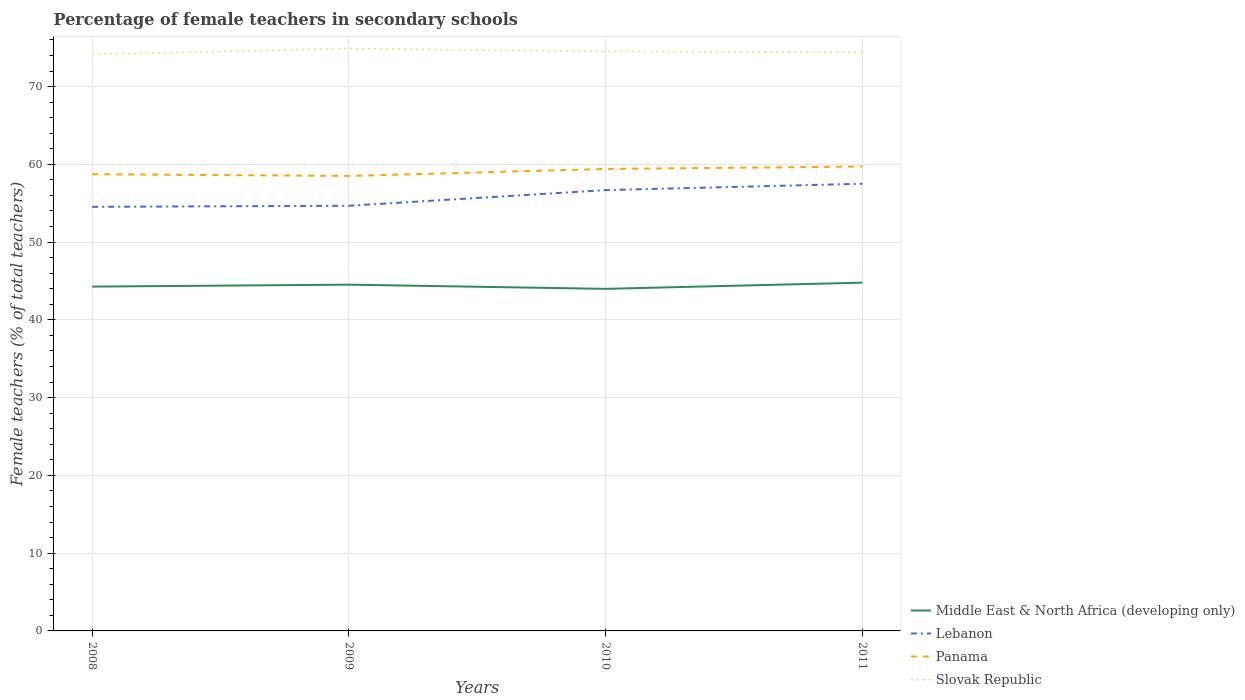Across all years, what is the maximum percentage of female teachers in Panama?
Offer a terse response. 58.5. What is the total percentage of female teachers in Slovak Republic in the graph?
Give a very brief answer. -0.74. What is the difference between the highest and the second highest percentage of female teachers in Middle East & North Africa (developing only)?
Ensure brevity in your answer.  0.8. Is the percentage of female teachers in Panama strictly greater than the percentage of female teachers in Lebanon over the years?
Provide a short and direct response. No. Are the values on the major ticks of Y-axis written in scientific E-notation?
Your answer should be very brief. No. Does the graph contain any zero values?
Offer a terse response. No. Does the graph contain grids?
Ensure brevity in your answer.  Yes. How many legend labels are there?
Offer a very short reply. 4. What is the title of the graph?
Provide a succinct answer. Percentage of female teachers in secondary schools. What is the label or title of the X-axis?
Your answer should be very brief. Years. What is the label or title of the Y-axis?
Provide a succinct answer. Female teachers (% of total teachers). What is the Female teachers (% of total teachers) of Middle East & North Africa (developing only) in 2008?
Your answer should be very brief. 44.28. What is the Female teachers (% of total teachers) in Lebanon in 2008?
Give a very brief answer. 54.53. What is the Female teachers (% of total teachers) in Panama in 2008?
Ensure brevity in your answer.  58.72. What is the Female teachers (% of total teachers) of Slovak Republic in 2008?
Offer a terse response. 74.15. What is the Female teachers (% of total teachers) of Middle East & North Africa (developing only) in 2009?
Make the answer very short. 44.53. What is the Female teachers (% of total teachers) of Lebanon in 2009?
Provide a succinct answer. 54.67. What is the Female teachers (% of total teachers) in Panama in 2009?
Ensure brevity in your answer.  58.5. What is the Female teachers (% of total teachers) of Slovak Republic in 2009?
Make the answer very short. 74.88. What is the Female teachers (% of total teachers) in Middle East & North Africa (developing only) in 2010?
Provide a short and direct response. 43.99. What is the Female teachers (% of total teachers) of Lebanon in 2010?
Your answer should be very brief. 56.68. What is the Female teachers (% of total teachers) of Panama in 2010?
Make the answer very short. 59.4. What is the Female teachers (% of total teachers) of Slovak Republic in 2010?
Provide a succinct answer. 74.52. What is the Female teachers (% of total teachers) of Middle East & North Africa (developing only) in 2011?
Offer a very short reply. 44.78. What is the Female teachers (% of total teachers) in Lebanon in 2011?
Provide a short and direct response. 57.5. What is the Female teachers (% of total teachers) in Panama in 2011?
Give a very brief answer. 59.72. What is the Female teachers (% of total teachers) of Slovak Republic in 2011?
Keep it short and to the point. 74.4. Across all years, what is the maximum Female teachers (% of total teachers) of Middle East & North Africa (developing only)?
Your answer should be compact. 44.78. Across all years, what is the maximum Female teachers (% of total teachers) of Lebanon?
Offer a very short reply. 57.5. Across all years, what is the maximum Female teachers (% of total teachers) of Panama?
Your answer should be very brief. 59.72. Across all years, what is the maximum Female teachers (% of total teachers) of Slovak Republic?
Provide a short and direct response. 74.88. Across all years, what is the minimum Female teachers (% of total teachers) in Middle East & North Africa (developing only)?
Make the answer very short. 43.99. Across all years, what is the minimum Female teachers (% of total teachers) in Lebanon?
Offer a very short reply. 54.53. Across all years, what is the minimum Female teachers (% of total teachers) of Panama?
Make the answer very short. 58.5. Across all years, what is the minimum Female teachers (% of total teachers) of Slovak Republic?
Offer a very short reply. 74.15. What is the total Female teachers (% of total teachers) of Middle East & North Africa (developing only) in the graph?
Your answer should be very brief. 177.57. What is the total Female teachers (% of total teachers) in Lebanon in the graph?
Offer a terse response. 223.39. What is the total Female teachers (% of total teachers) in Panama in the graph?
Your response must be concise. 236.35. What is the total Female teachers (% of total teachers) of Slovak Republic in the graph?
Your answer should be compact. 297.95. What is the difference between the Female teachers (% of total teachers) of Middle East & North Africa (developing only) in 2008 and that in 2009?
Your answer should be very brief. -0.25. What is the difference between the Female teachers (% of total teachers) of Lebanon in 2008 and that in 2009?
Your answer should be compact. -0.14. What is the difference between the Female teachers (% of total teachers) in Panama in 2008 and that in 2009?
Your answer should be compact. 0.22. What is the difference between the Female teachers (% of total teachers) in Slovak Republic in 2008 and that in 2009?
Offer a very short reply. -0.74. What is the difference between the Female teachers (% of total teachers) in Middle East & North Africa (developing only) in 2008 and that in 2010?
Provide a succinct answer. 0.29. What is the difference between the Female teachers (% of total teachers) in Lebanon in 2008 and that in 2010?
Your answer should be compact. -2.15. What is the difference between the Female teachers (% of total teachers) of Panama in 2008 and that in 2010?
Your answer should be compact. -0.68. What is the difference between the Female teachers (% of total teachers) in Slovak Republic in 2008 and that in 2010?
Ensure brevity in your answer.  -0.38. What is the difference between the Female teachers (% of total teachers) of Middle East & North Africa (developing only) in 2008 and that in 2011?
Your answer should be compact. -0.51. What is the difference between the Female teachers (% of total teachers) in Lebanon in 2008 and that in 2011?
Your answer should be compact. -2.97. What is the difference between the Female teachers (% of total teachers) in Panama in 2008 and that in 2011?
Give a very brief answer. -0.99. What is the difference between the Female teachers (% of total teachers) of Slovak Republic in 2008 and that in 2011?
Give a very brief answer. -0.25. What is the difference between the Female teachers (% of total teachers) in Middle East & North Africa (developing only) in 2009 and that in 2010?
Ensure brevity in your answer.  0.54. What is the difference between the Female teachers (% of total teachers) of Lebanon in 2009 and that in 2010?
Provide a short and direct response. -2.01. What is the difference between the Female teachers (% of total teachers) of Panama in 2009 and that in 2010?
Give a very brief answer. -0.9. What is the difference between the Female teachers (% of total teachers) in Slovak Republic in 2009 and that in 2010?
Offer a very short reply. 0.36. What is the difference between the Female teachers (% of total teachers) of Middle East & North Africa (developing only) in 2009 and that in 2011?
Your answer should be compact. -0.26. What is the difference between the Female teachers (% of total teachers) in Lebanon in 2009 and that in 2011?
Offer a terse response. -2.83. What is the difference between the Female teachers (% of total teachers) in Panama in 2009 and that in 2011?
Offer a terse response. -1.22. What is the difference between the Female teachers (% of total teachers) in Slovak Republic in 2009 and that in 2011?
Provide a short and direct response. 0.49. What is the difference between the Female teachers (% of total teachers) of Middle East & North Africa (developing only) in 2010 and that in 2011?
Provide a short and direct response. -0.8. What is the difference between the Female teachers (% of total teachers) in Lebanon in 2010 and that in 2011?
Give a very brief answer. -0.82. What is the difference between the Female teachers (% of total teachers) of Panama in 2010 and that in 2011?
Provide a succinct answer. -0.32. What is the difference between the Female teachers (% of total teachers) in Slovak Republic in 2010 and that in 2011?
Ensure brevity in your answer.  0.13. What is the difference between the Female teachers (% of total teachers) in Middle East & North Africa (developing only) in 2008 and the Female teachers (% of total teachers) in Lebanon in 2009?
Ensure brevity in your answer.  -10.4. What is the difference between the Female teachers (% of total teachers) of Middle East & North Africa (developing only) in 2008 and the Female teachers (% of total teachers) of Panama in 2009?
Offer a terse response. -14.23. What is the difference between the Female teachers (% of total teachers) of Middle East & North Africa (developing only) in 2008 and the Female teachers (% of total teachers) of Slovak Republic in 2009?
Your answer should be compact. -30.61. What is the difference between the Female teachers (% of total teachers) of Lebanon in 2008 and the Female teachers (% of total teachers) of Panama in 2009?
Offer a terse response. -3.97. What is the difference between the Female teachers (% of total teachers) in Lebanon in 2008 and the Female teachers (% of total teachers) in Slovak Republic in 2009?
Give a very brief answer. -20.35. What is the difference between the Female teachers (% of total teachers) in Panama in 2008 and the Female teachers (% of total teachers) in Slovak Republic in 2009?
Make the answer very short. -16.16. What is the difference between the Female teachers (% of total teachers) of Middle East & North Africa (developing only) in 2008 and the Female teachers (% of total teachers) of Lebanon in 2010?
Give a very brief answer. -12.41. What is the difference between the Female teachers (% of total teachers) in Middle East & North Africa (developing only) in 2008 and the Female teachers (% of total teachers) in Panama in 2010?
Keep it short and to the point. -15.13. What is the difference between the Female teachers (% of total teachers) of Middle East & North Africa (developing only) in 2008 and the Female teachers (% of total teachers) of Slovak Republic in 2010?
Provide a short and direct response. -30.25. What is the difference between the Female teachers (% of total teachers) of Lebanon in 2008 and the Female teachers (% of total teachers) of Panama in 2010?
Your answer should be very brief. -4.87. What is the difference between the Female teachers (% of total teachers) of Lebanon in 2008 and the Female teachers (% of total teachers) of Slovak Republic in 2010?
Offer a very short reply. -19.99. What is the difference between the Female teachers (% of total teachers) in Panama in 2008 and the Female teachers (% of total teachers) in Slovak Republic in 2010?
Offer a terse response. -15.8. What is the difference between the Female teachers (% of total teachers) in Middle East & North Africa (developing only) in 2008 and the Female teachers (% of total teachers) in Lebanon in 2011?
Your answer should be very brief. -13.23. What is the difference between the Female teachers (% of total teachers) in Middle East & North Africa (developing only) in 2008 and the Female teachers (% of total teachers) in Panama in 2011?
Keep it short and to the point. -15.44. What is the difference between the Female teachers (% of total teachers) in Middle East & North Africa (developing only) in 2008 and the Female teachers (% of total teachers) in Slovak Republic in 2011?
Your answer should be compact. -30.12. What is the difference between the Female teachers (% of total teachers) of Lebanon in 2008 and the Female teachers (% of total teachers) of Panama in 2011?
Your answer should be very brief. -5.19. What is the difference between the Female teachers (% of total teachers) of Lebanon in 2008 and the Female teachers (% of total teachers) of Slovak Republic in 2011?
Your answer should be very brief. -19.86. What is the difference between the Female teachers (% of total teachers) of Panama in 2008 and the Female teachers (% of total teachers) of Slovak Republic in 2011?
Ensure brevity in your answer.  -15.67. What is the difference between the Female teachers (% of total teachers) of Middle East & North Africa (developing only) in 2009 and the Female teachers (% of total teachers) of Lebanon in 2010?
Ensure brevity in your answer.  -12.16. What is the difference between the Female teachers (% of total teachers) in Middle East & North Africa (developing only) in 2009 and the Female teachers (% of total teachers) in Panama in 2010?
Give a very brief answer. -14.88. What is the difference between the Female teachers (% of total teachers) in Middle East & North Africa (developing only) in 2009 and the Female teachers (% of total teachers) in Slovak Republic in 2010?
Your answer should be very brief. -30. What is the difference between the Female teachers (% of total teachers) in Lebanon in 2009 and the Female teachers (% of total teachers) in Panama in 2010?
Your answer should be very brief. -4.73. What is the difference between the Female teachers (% of total teachers) of Lebanon in 2009 and the Female teachers (% of total teachers) of Slovak Republic in 2010?
Offer a very short reply. -19.85. What is the difference between the Female teachers (% of total teachers) of Panama in 2009 and the Female teachers (% of total teachers) of Slovak Republic in 2010?
Your answer should be compact. -16.02. What is the difference between the Female teachers (% of total teachers) of Middle East & North Africa (developing only) in 2009 and the Female teachers (% of total teachers) of Lebanon in 2011?
Give a very brief answer. -12.98. What is the difference between the Female teachers (% of total teachers) in Middle East & North Africa (developing only) in 2009 and the Female teachers (% of total teachers) in Panama in 2011?
Provide a succinct answer. -15.19. What is the difference between the Female teachers (% of total teachers) in Middle East & North Africa (developing only) in 2009 and the Female teachers (% of total teachers) in Slovak Republic in 2011?
Provide a succinct answer. -29.87. What is the difference between the Female teachers (% of total teachers) of Lebanon in 2009 and the Female teachers (% of total teachers) of Panama in 2011?
Ensure brevity in your answer.  -5.05. What is the difference between the Female teachers (% of total teachers) of Lebanon in 2009 and the Female teachers (% of total teachers) of Slovak Republic in 2011?
Keep it short and to the point. -19.72. What is the difference between the Female teachers (% of total teachers) in Panama in 2009 and the Female teachers (% of total teachers) in Slovak Republic in 2011?
Give a very brief answer. -15.89. What is the difference between the Female teachers (% of total teachers) in Middle East & North Africa (developing only) in 2010 and the Female teachers (% of total teachers) in Lebanon in 2011?
Offer a very short reply. -13.52. What is the difference between the Female teachers (% of total teachers) in Middle East & North Africa (developing only) in 2010 and the Female teachers (% of total teachers) in Panama in 2011?
Keep it short and to the point. -15.73. What is the difference between the Female teachers (% of total teachers) in Middle East & North Africa (developing only) in 2010 and the Female teachers (% of total teachers) in Slovak Republic in 2011?
Give a very brief answer. -30.41. What is the difference between the Female teachers (% of total teachers) in Lebanon in 2010 and the Female teachers (% of total teachers) in Panama in 2011?
Keep it short and to the point. -3.03. What is the difference between the Female teachers (% of total teachers) in Lebanon in 2010 and the Female teachers (% of total teachers) in Slovak Republic in 2011?
Ensure brevity in your answer.  -17.71. What is the difference between the Female teachers (% of total teachers) of Panama in 2010 and the Female teachers (% of total teachers) of Slovak Republic in 2011?
Your answer should be very brief. -14.99. What is the average Female teachers (% of total teachers) of Middle East & North Africa (developing only) per year?
Make the answer very short. 44.39. What is the average Female teachers (% of total teachers) in Lebanon per year?
Your response must be concise. 55.85. What is the average Female teachers (% of total teachers) in Panama per year?
Make the answer very short. 59.09. What is the average Female teachers (% of total teachers) in Slovak Republic per year?
Offer a very short reply. 74.49. In the year 2008, what is the difference between the Female teachers (% of total teachers) in Middle East & North Africa (developing only) and Female teachers (% of total teachers) in Lebanon?
Give a very brief answer. -10.26. In the year 2008, what is the difference between the Female teachers (% of total teachers) of Middle East & North Africa (developing only) and Female teachers (% of total teachers) of Panama?
Your answer should be compact. -14.45. In the year 2008, what is the difference between the Female teachers (% of total teachers) in Middle East & North Africa (developing only) and Female teachers (% of total teachers) in Slovak Republic?
Your answer should be compact. -29.87. In the year 2008, what is the difference between the Female teachers (% of total teachers) of Lebanon and Female teachers (% of total teachers) of Panama?
Provide a short and direct response. -4.19. In the year 2008, what is the difference between the Female teachers (% of total teachers) in Lebanon and Female teachers (% of total teachers) in Slovak Republic?
Keep it short and to the point. -19.61. In the year 2008, what is the difference between the Female teachers (% of total teachers) of Panama and Female teachers (% of total teachers) of Slovak Republic?
Offer a terse response. -15.42. In the year 2009, what is the difference between the Female teachers (% of total teachers) of Middle East & North Africa (developing only) and Female teachers (% of total teachers) of Lebanon?
Make the answer very short. -10.15. In the year 2009, what is the difference between the Female teachers (% of total teachers) of Middle East & North Africa (developing only) and Female teachers (% of total teachers) of Panama?
Your answer should be compact. -13.98. In the year 2009, what is the difference between the Female teachers (% of total teachers) in Middle East & North Africa (developing only) and Female teachers (% of total teachers) in Slovak Republic?
Offer a very short reply. -30.36. In the year 2009, what is the difference between the Female teachers (% of total teachers) in Lebanon and Female teachers (% of total teachers) in Panama?
Your answer should be compact. -3.83. In the year 2009, what is the difference between the Female teachers (% of total teachers) of Lebanon and Female teachers (% of total teachers) of Slovak Republic?
Keep it short and to the point. -20.21. In the year 2009, what is the difference between the Female teachers (% of total teachers) of Panama and Female teachers (% of total teachers) of Slovak Republic?
Make the answer very short. -16.38. In the year 2010, what is the difference between the Female teachers (% of total teachers) of Middle East & North Africa (developing only) and Female teachers (% of total teachers) of Lebanon?
Keep it short and to the point. -12.7. In the year 2010, what is the difference between the Female teachers (% of total teachers) in Middle East & North Africa (developing only) and Female teachers (% of total teachers) in Panama?
Ensure brevity in your answer.  -15.42. In the year 2010, what is the difference between the Female teachers (% of total teachers) in Middle East & North Africa (developing only) and Female teachers (% of total teachers) in Slovak Republic?
Your response must be concise. -30.54. In the year 2010, what is the difference between the Female teachers (% of total teachers) in Lebanon and Female teachers (% of total teachers) in Panama?
Offer a very short reply. -2.72. In the year 2010, what is the difference between the Female teachers (% of total teachers) in Lebanon and Female teachers (% of total teachers) in Slovak Republic?
Make the answer very short. -17.84. In the year 2010, what is the difference between the Female teachers (% of total teachers) in Panama and Female teachers (% of total teachers) in Slovak Republic?
Make the answer very short. -15.12. In the year 2011, what is the difference between the Female teachers (% of total teachers) of Middle East & North Africa (developing only) and Female teachers (% of total teachers) of Lebanon?
Offer a terse response. -12.72. In the year 2011, what is the difference between the Female teachers (% of total teachers) of Middle East & North Africa (developing only) and Female teachers (% of total teachers) of Panama?
Ensure brevity in your answer.  -14.93. In the year 2011, what is the difference between the Female teachers (% of total teachers) in Middle East & North Africa (developing only) and Female teachers (% of total teachers) in Slovak Republic?
Offer a terse response. -29.61. In the year 2011, what is the difference between the Female teachers (% of total teachers) of Lebanon and Female teachers (% of total teachers) of Panama?
Offer a very short reply. -2.21. In the year 2011, what is the difference between the Female teachers (% of total teachers) in Lebanon and Female teachers (% of total teachers) in Slovak Republic?
Give a very brief answer. -16.89. In the year 2011, what is the difference between the Female teachers (% of total teachers) in Panama and Female teachers (% of total teachers) in Slovak Republic?
Your response must be concise. -14.68. What is the ratio of the Female teachers (% of total teachers) of Middle East & North Africa (developing only) in 2008 to that in 2009?
Offer a terse response. 0.99. What is the ratio of the Female teachers (% of total teachers) of Lebanon in 2008 to that in 2009?
Keep it short and to the point. 1. What is the ratio of the Female teachers (% of total teachers) of Panama in 2008 to that in 2009?
Provide a short and direct response. 1. What is the ratio of the Female teachers (% of total teachers) of Slovak Republic in 2008 to that in 2009?
Offer a very short reply. 0.99. What is the ratio of the Female teachers (% of total teachers) in Middle East & North Africa (developing only) in 2008 to that in 2010?
Your answer should be very brief. 1.01. What is the ratio of the Female teachers (% of total teachers) in Lebanon in 2008 to that in 2010?
Your response must be concise. 0.96. What is the ratio of the Female teachers (% of total teachers) in Slovak Republic in 2008 to that in 2010?
Your answer should be very brief. 0.99. What is the ratio of the Female teachers (% of total teachers) of Lebanon in 2008 to that in 2011?
Ensure brevity in your answer.  0.95. What is the ratio of the Female teachers (% of total teachers) in Panama in 2008 to that in 2011?
Keep it short and to the point. 0.98. What is the ratio of the Female teachers (% of total teachers) in Slovak Republic in 2008 to that in 2011?
Ensure brevity in your answer.  1. What is the ratio of the Female teachers (% of total teachers) of Middle East & North Africa (developing only) in 2009 to that in 2010?
Provide a short and direct response. 1.01. What is the ratio of the Female teachers (% of total teachers) of Lebanon in 2009 to that in 2010?
Offer a very short reply. 0.96. What is the ratio of the Female teachers (% of total teachers) of Panama in 2009 to that in 2010?
Ensure brevity in your answer.  0.98. What is the ratio of the Female teachers (% of total teachers) in Slovak Republic in 2009 to that in 2010?
Provide a succinct answer. 1. What is the ratio of the Female teachers (% of total teachers) in Middle East & North Africa (developing only) in 2009 to that in 2011?
Your answer should be very brief. 0.99. What is the ratio of the Female teachers (% of total teachers) in Lebanon in 2009 to that in 2011?
Offer a terse response. 0.95. What is the ratio of the Female teachers (% of total teachers) in Panama in 2009 to that in 2011?
Your response must be concise. 0.98. What is the ratio of the Female teachers (% of total teachers) in Slovak Republic in 2009 to that in 2011?
Give a very brief answer. 1.01. What is the ratio of the Female teachers (% of total teachers) in Middle East & North Africa (developing only) in 2010 to that in 2011?
Keep it short and to the point. 0.98. What is the ratio of the Female teachers (% of total teachers) of Lebanon in 2010 to that in 2011?
Your answer should be compact. 0.99. What is the ratio of the Female teachers (% of total teachers) of Slovak Republic in 2010 to that in 2011?
Offer a terse response. 1. What is the difference between the highest and the second highest Female teachers (% of total teachers) of Middle East & North Africa (developing only)?
Offer a very short reply. 0.26. What is the difference between the highest and the second highest Female teachers (% of total teachers) in Lebanon?
Your answer should be very brief. 0.82. What is the difference between the highest and the second highest Female teachers (% of total teachers) in Panama?
Your answer should be compact. 0.32. What is the difference between the highest and the second highest Female teachers (% of total teachers) in Slovak Republic?
Your answer should be very brief. 0.36. What is the difference between the highest and the lowest Female teachers (% of total teachers) in Middle East & North Africa (developing only)?
Keep it short and to the point. 0.8. What is the difference between the highest and the lowest Female teachers (% of total teachers) of Lebanon?
Offer a terse response. 2.97. What is the difference between the highest and the lowest Female teachers (% of total teachers) in Panama?
Keep it short and to the point. 1.22. What is the difference between the highest and the lowest Female teachers (% of total teachers) of Slovak Republic?
Ensure brevity in your answer.  0.74. 